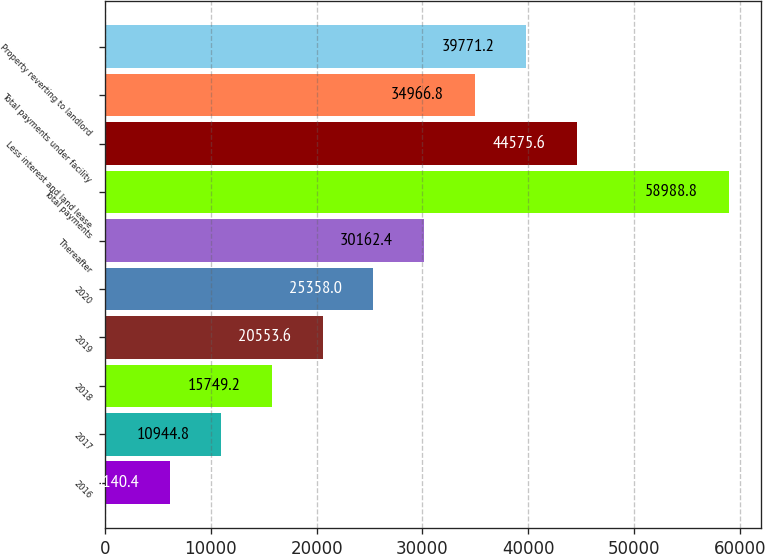Convert chart to OTSL. <chart><loc_0><loc_0><loc_500><loc_500><bar_chart><fcel>2016<fcel>2017<fcel>2018<fcel>2019<fcel>2020<fcel>Thereafter<fcel>Total payments<fcel>Less interest and land lease<fcel>Total payments under facility<fcel>Property reverting to landlord<nl><fcel>6140.4<fcel>10944.8<fcel>15749.2<fcel>20553.6<fcel>25358<fcel>30162.4<fcel>58988.8<fcel>44575.6<fcel>34966.8<fcel>39771.2<nl></chart> 